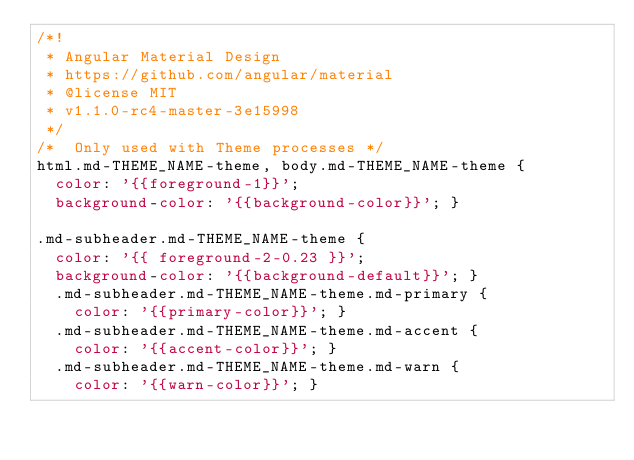<code> <loc_0><loc_0><loc_500><loc_500><_CSS_>/*!
 * Angular Material Design
 * https://github.com/angular/material
 * @license MIT
 * v1.1.0-rc4-master-3e15998
 */
/*  Only used with Theme processes */
html.md-THEME_NAME-theme, body.md-THEME_NAME-theme {
  color: '{{foreground-1}}';
  background-color: '{{background-color}}'; }

.md-subheader.md-THEME_NAME-theme {
  color: '{{ foreground-2-0.23 }}';
  background-color: '{{background-default}}'; }
  .md-subheader.md-THEME_NAME-theme.md-primary {
    color: '{{primary-color}}'; }
  .md-subheader.md-THEME_NAME-theme.md-accent {
    color: '{{accent-color}}'; }
  .md-subheader.md-THEME_NAME-theme.md-warn {
    color: '{{warn-color}}'; }
</code> 